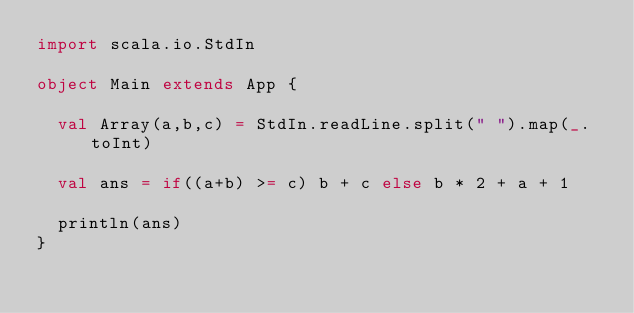<code> <loc_0><loc_0><loc_500><loc_500><_Scala_>import scala.io.StdIn

object Main extends App {

  val Array(a,b,c) = StdIn.readLine.split(" ").map(_.toInt)

  val ans = if((a+b) >= c) b + c else b * 2 + a + 1

  println(ans)
}</code> 